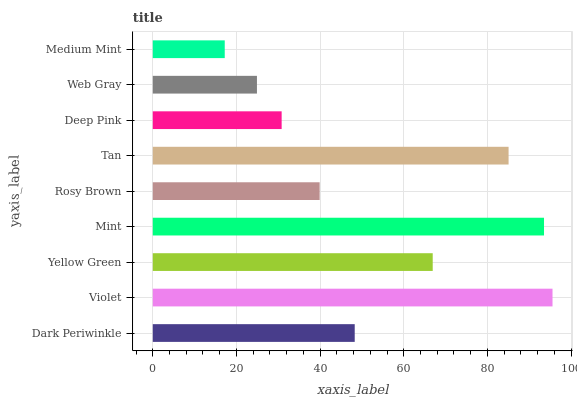Is Medium Mint the minimum?
Answer yes or no. Yes. Is Violet the maximum?
Answer yes or no. Yes. Is Yellow Green the minimum?
Answer yes or no. No. Is Yellow Green the maximum?
Answer yes or no. No. Is Violet greater than Yellow Green?
Answer yes or no. Yes. Is Yellow Green less than Violet?
Answer yes or no. Yes. Is Yellow Green greater than Violet?
Answer yes or no. No. Is Violet less than Yellow Green?
Answer yes or no. No. Is Dark Periwinkle the high median?
Answer yes or no. Yes. Is Dark Periwinkle the low median?
Answer yes or no. Yes. Is Deep Pink the high median?
Answer yes or no. No. Is Mint the low median?
Answer yes or no. No. 